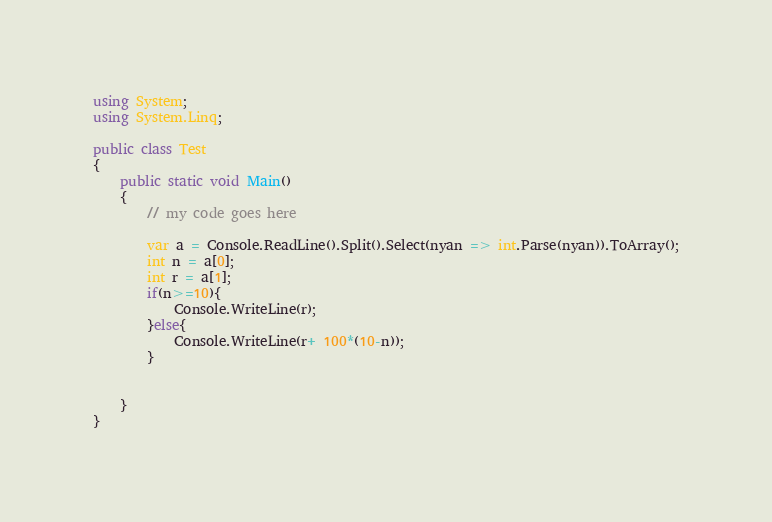Convert code to text. <code><loc_0><loc_0><loc_500><loc_500><_C#_>using System;
using System.Linq;

public class Test
{
	public static void Main()
	{
		// my code goes here
		
		var a = Console.ReadLine().Split().Select(nyan => int.Parse(nyan)).ToArray();
		int n = a[0];
		int r = a[1];
		if(n>=10){
			Console.WriteLine(r);
		}else{
			Console.WriteLine(r+ 100*(10-n));
		}
		
		
	}
}</code> 